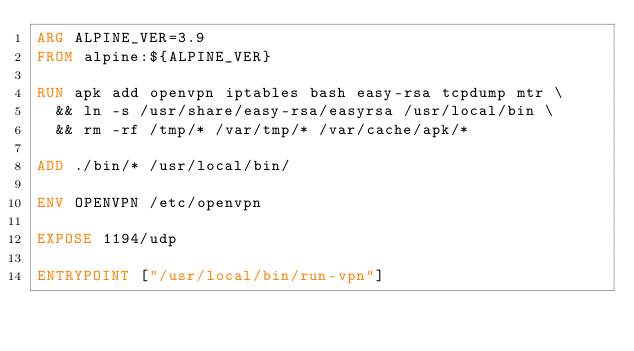Convert code to text. <code><loc_0><loc_0><loc_500><loc_500><_Dockerfile_>ARG ALPINE_VER=3.9
FROM alpine:${ALPINE_VER}

RUN apk add openvpn iptables bash easy-rsa tcpdump mtr \
  && ln -s /usr/share/easy-rsa/easyrsa /usr/local/bin \
  && rm -rf /tmp/* /var/tmp/* /var/cache/apk/*

ADD ./bin/* /usr/local/bin/

ENV OPENVPN /etc/openvpn

EXPOSE 1194/udp

ENTRYPOINT ["/usr/local/bin/run-vpn"]
</code> 